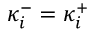Convert formula to latex. <formula><loc_0><loc_0><loc_500><loc_500>\kappa _ { i } ^ { - } = \kappa _ { i } ^ { + }</formula> 